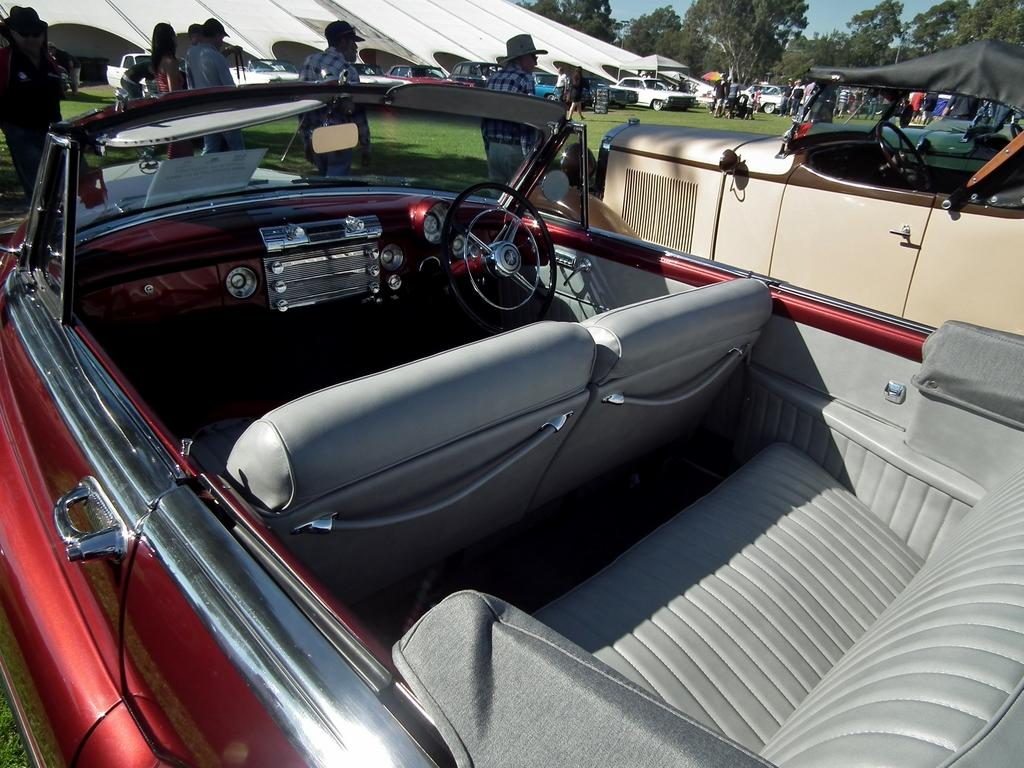What is the main subject of the image? The main subject of the image is two cars on a greenery ground. What are the people in the image doing? The people are standing in front of the cars. Can you describe the background of the image? There are cars, people, and trees in the background of the image. What is the price of the car being discussed by the people in the image? There is no indication in the image that the people are discussing the price of a car, so it cannot be determined from the picture. 